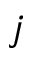Convert formula to latex. <formula><loc_0><loc_0><loc_500><loc_500>j</formula> 